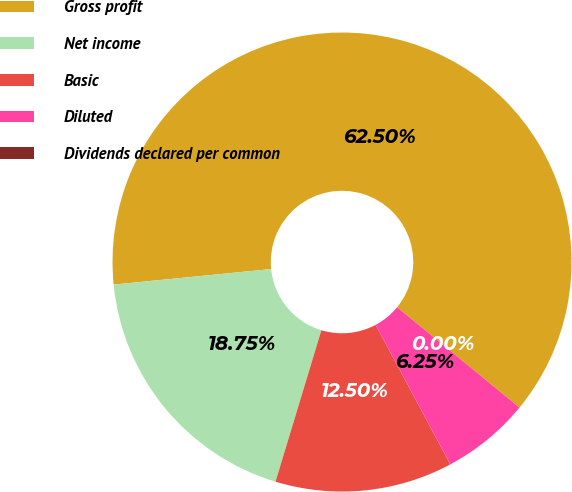Convert chart to OTSL. <chart><loc_0><loc_0><loc_500><loc_500><pie_chart><fcel>Gross profit<fcel>Net income<fcel>Basic<fcel>Diluted<fcel>Dividends declared per common<nl><fcel>62.49%<fcel>18.75%<fcel>12.5%<fcel>6.25%<fcel>0.0%<nl></chart> 